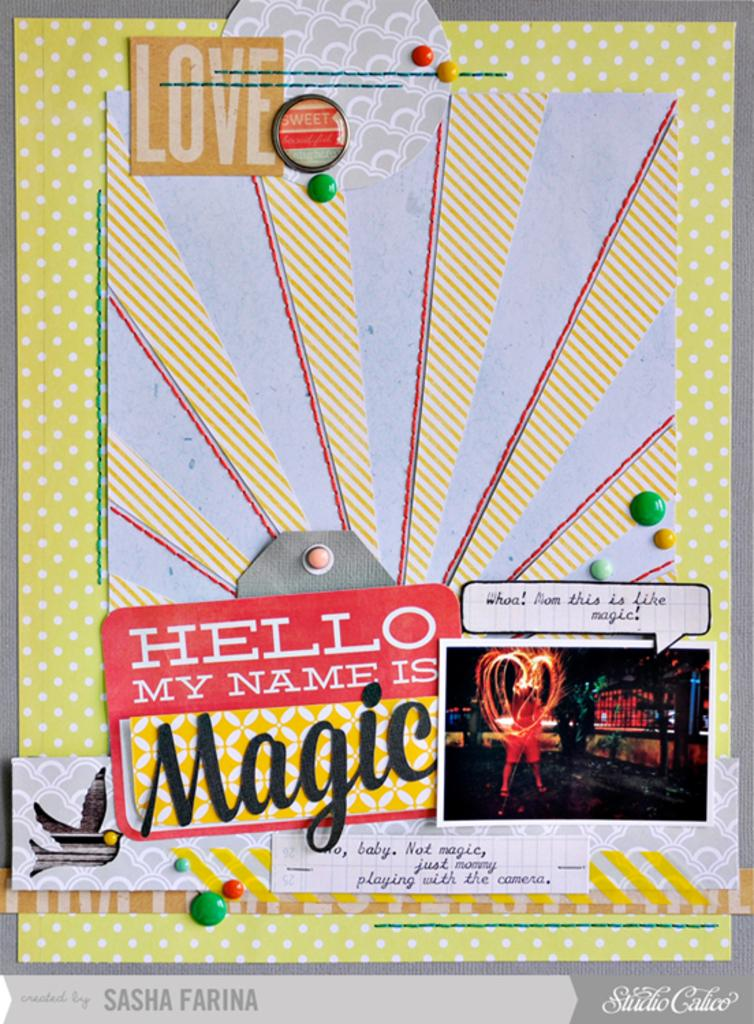<image>
Render a clear and concise summary of the photo. A board with pins has Studio Calico in the lower right corner. 